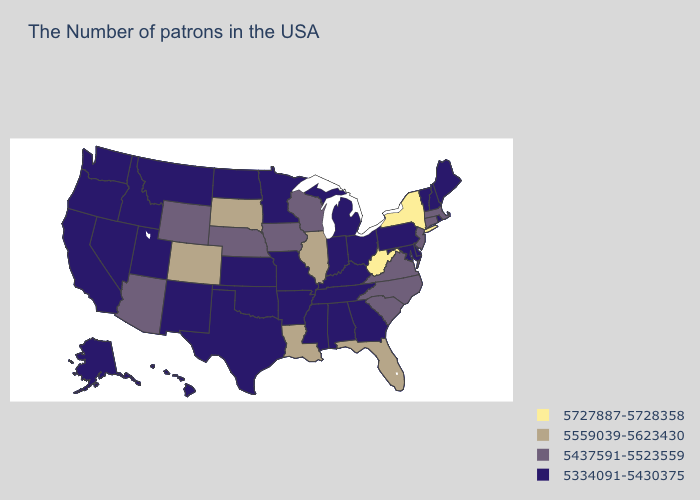Name the states that have a value in the range 5727887-5728358?
Concise answer only. New York, West Virginia. Which states have the highest value in the USA?
Concise answer only. New York, West Virginia. Which states have the lowest value in the USA?
Answer briefly. Maine, Rhode Island, New Hampshire, Vermont, Delaware, Maryland, Pennsylvania, Ohio, Georgia, Michigan, Kentucky, Indiana, Alabama, Tennessee, Mississippi, Missouri, Arkansas, Minnesota, Kansas, Oklahoma, Texas, North Dakota, New Mexico, Utah, Montana, Idaho, Nevada, California, Washington, Oregon, Alaska, Hawaii. What is the highest value in states that border Alabama?
Give a very brief answer. 5559039-5623430. What is the lowest value in the MidWest?
Quick response, please. 5334091-5430375. What is the value of Ohio?
Short answer required. 5334091-5430375. What is the lowest value in states that border Montana?
Give a very brief answer. 5334091-5430375. What is the value of Wyoming?
Concise answer only. 5437591-5523559. Which states have the highest value in the USA?
Write a very short answer. New York, West Virginia. What is the value of Nebraska?
Short answer required. 5437591-5523559. What is the value of Iowa?
Quick response, please. 5437591-5523559. Does California have the highest value in the USA?
Give a very brief answer. No. Does Nebraska have the lowest value in the MidWest?
Short answer required. No. What is the value of Utah?
Give a very brief answer. 5334091-5430375. Is the legend a continuous bar?
Answer briefly. No. 